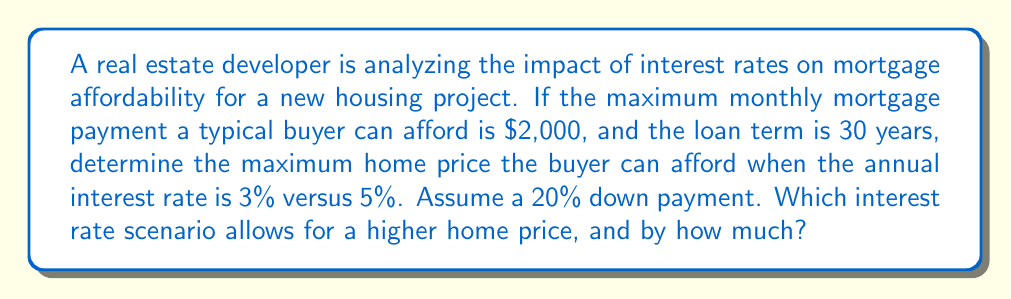Could you help me with this problem? Let's approach this step-by-step:

1) First, we need to use the mortgage payment formula:
   $$ P = L \frac{r(1+r)^n}{(1+r)^n - 1} $$
   Where:
   $P$ = monthly payment
   $L$ = loan amount
   $r$ = monthly interest rate (annual rate divided by 12)
   $n$ = total number of months (years * 12)

2) We know $P = 2000$, $n = 30 * 12 = 360$

3) For 3% annual interest rate:
   $r = 0.03 / 12 = 0.0025$
   
   $2000 = L \frac{0.0025(1+0.0025)^{360}}{(1+0.0025)^{360} - 1}$

4) Solving for $L$:
   $L = 2000 * \frac{(1+0.0025)^{360} - 1}{0.0025(1+0.0025)^{360}} \approx 474,075.91$

5) This $L$ represents 80% of the total home price (due to 20% down payment)
   Total home price at 3% = $474,075.91 / 0.8 \approx 592,594.89$

6) Repeat steps 3-5 for 5% annual interest rate:
   $r = 0.05 / 12 = 0.004167$
   
   $L = 2000 * \frac{(1+0.004167)^{360} - 1}{0.004167(1+0.004167)^{360}} \approx 372,539.44$
   
   Total home price at 5% = $372,539.44 / 0.8 \approx 465,674.30$

7) Difference in home prices:
   $592,594.89 - 465,674.30 = 126,920.59$
Answer: 3% rate allows $126,920.59 higher home price 